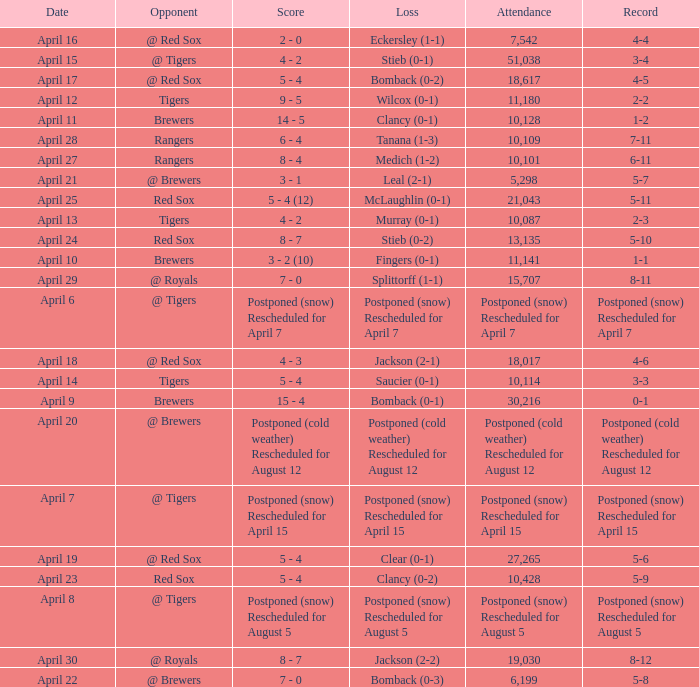What was the date for the game that had an attendance of 10,101? April 27. 